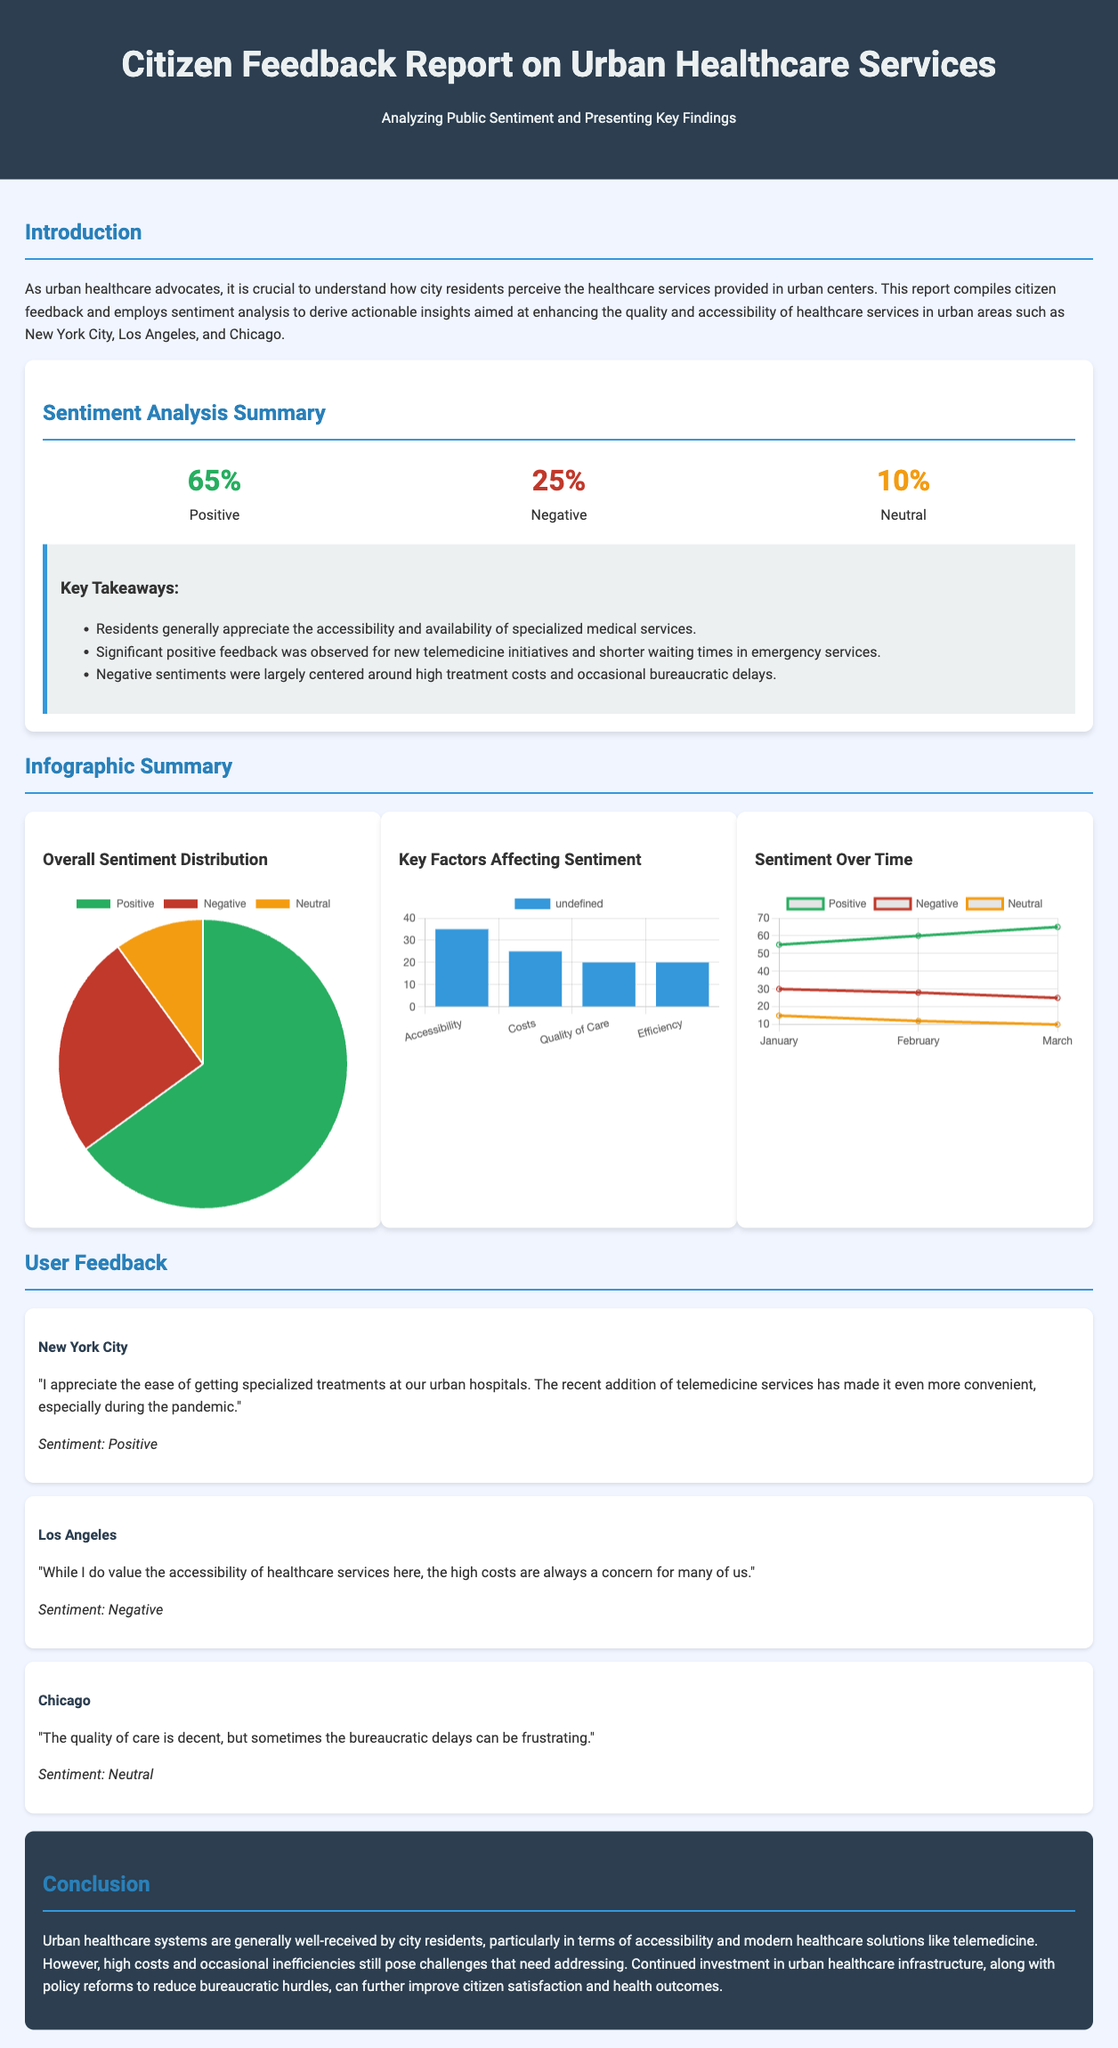What is the percentage of positive sentiment? The percentage of positive sentiment is highlighted in the sentiment analysis summary, which shows 65%.
Answer: 65% What city reported high treatment costs as a concern? The user feedback section includes a comment from a resident in Los Angeles expressing concern over high costs.
Answer: Los Angeles What are the key factors affecting sentiment? The report lists Accessibility, Costs, Quality of Care, and Efficiency as key factors in the bar chart section.
Answer: Accessibility, Costs, Quality of Care, Efficiency What was the sentiment percentage for neutral feedback? The sentiment analysis summary specifies that 10% of the feedback was neutral.
Answer: 10% How many months were analyzed for sentiment over time? The line graph presents data for three months: January, February, and March.
Answer: Three months Which city experienced positive sentiment regarding telemedicine services? The feedback from New York City indicates a positive sentiment toward telemedicine services.
Answer: New York City What conclusion is drawn about urban healthcare systems? The conclusion emphasizes that urban healthcare systems are generally well-received regarding accessibility and modern solutions.
Answer: Generally well-received What is the color associated with negative sentiment in the report? The sentiment chart indicates that the color associated with negative sentiment is red, as shown in the pie chart.
Answer: Red 